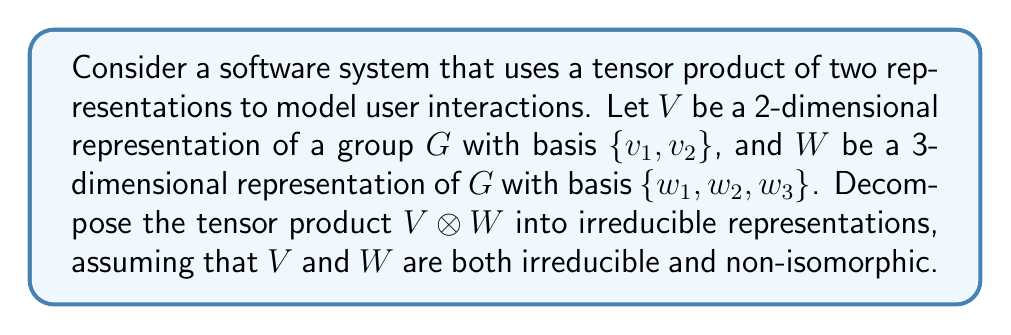Help me with this question. To decompose the tensor product $V \otimes W$, we'll follow these steps:

1) First, recall that for irreducible, non-isomorphic representations $V$ and $W$, their tensor product $V \otimes W$ is also irreducible.

2) The dimension of $V \otimes W$ is the product of the dimensions of $V$ and $W$:
   $$\dim(V \otimes W) = \dim(V) \cdot \dim(W) = 2 \cdot 3 = 6$$

3) A basis for $V \otimes W$ can be constructed by taking all possible tensor products of basis elements from $V$ and $W$:
   $$\{v_1 \otimes w_1, v_1 \otimes w_2, v_1 \otimes w_3, v_2 \otimes w_1, v_2 \otimes w_2, v_2 \otimes w_3\}$$

4) Since $V$ and $W$ are irreducible and non-isomorphic, $V \otimes W$ is itself an irreducible representation of dimension 6.

5) Therefore, the decomposition of $V \otimes W$ into irreducible representations is simply:
   $$V \otimes W = U$$
   where $U$ is a 6-dimensional irreducible representation of $G$.

In the context of software development, this decomposition could represent a complex user interaction model that cannot be further simplified into independent components.
Answer: $V \otimes W = U$, where $U$ is a 6-dimensional irreducible representation 